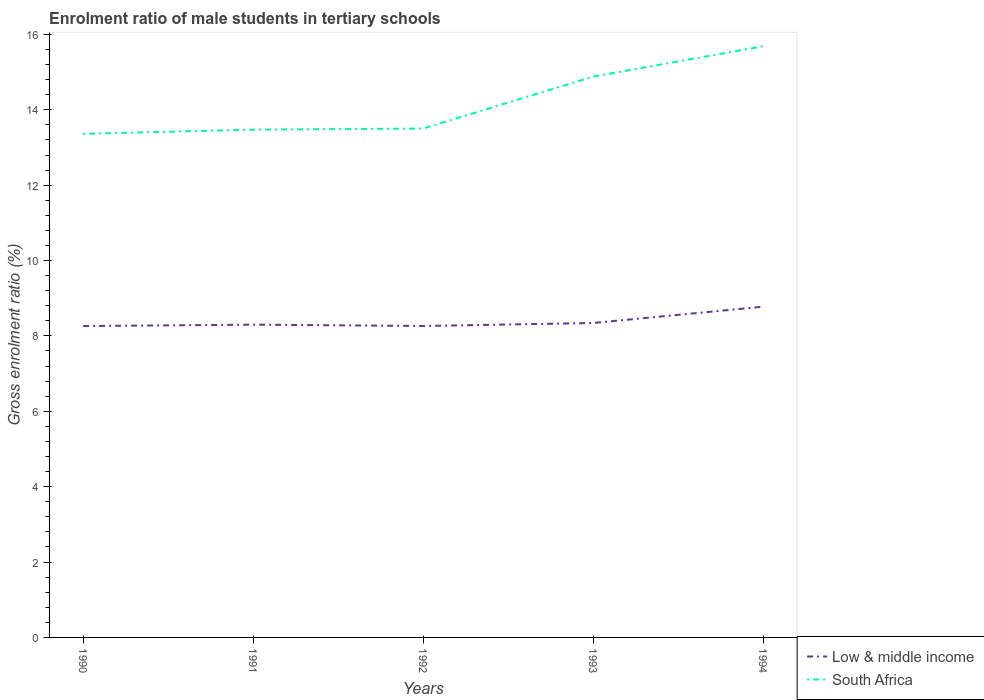How many different coloured lines are there?
Offer a terse response. 2. Is the number of lines equal to the number of legend labels?
Ensure brevity in your answer.  Yes. Across all years, what is the maximum enrolment ratio of male students in tertiary schools in South Africa?
Offer a very short reply. 13.36. What is the total enrolment ratio of male students in tertiary schools in South Africa in the graph?
Your answer should be compact. -1.41. What is the difference between the highest and the second highest enrolment ratio of male students in tertiary schools in South Africa?
Your answer should be compact. 2.32. Is the enrolment ratio of male students in tertiary schools in South Africa strictly greater than the enrolment ratio of male students in tertiary schools in Low & middle income over the years?
Keep it short and to the point. No. How many lines are there?
Offer a very short reply. 2. How many years are there in the graph?
Give a very brief answer. 5. Are the values on the major ticks of Y-axis written in scientific E-notation?
Provide a short and direct response. No. Does the graph contain any zero values?
Ensure brevity in your answer.  No. How many legend labels are there?
Offer a very short reply. 2. How are the legend labels stacked?
Provide a short and direct response. Vertical. What is the title of the graph?
Provide a short and direct response. Enrolment ratio of male students in tertiary schools. What is the label or title of the Y-axis?
Give a very brief answer. Gross enrolment ratio (%). What is the Gross enrolment ratio (%) in Low & middle income in 1990?
Your answer should be very brief. 8.26. What is the Gross enrolment ratio (%) in South Africa in 1990?
Provide a succinct answer. 13.36. What is the Gross enrolment ratio (%) of Low & middle income in 1991?
Ensure brevity in your answer.  8.3. What is the Gross enrolment ratio (%) in South Africa in 1991?
Provide a short and direct response. 13.47. What is the Gross enrolment ratio (%) of Low & middle income in 1992?
Offer a very short reply. 8.26. What is the Gross enrolment ratio (%) of South Africa in 1992?
Keep it short and to the point. 13.5. What is the Gross enrolment ratio (%) in Low & middle income in 1993?
Offer a terse response. 8.34. What is the Gross enrolment ratio (%) in South Africa in 1993?
Provide a succinct answer. 14.88. What is the Gross enrolment ratio (%) of Low & middle income in 1994?
Make the answer very short. 8.78. What is the Gross enrolment ratio (%) in South Africa in 1994?
Make the answer very short. 15.69. Across all years, what is the maximum Gross enrolment ratio (%) of Low & middle income?
Ensure brevity in your answer.  8.78. Across all years, what is the maximum Gross enrolment ratio (%) of South Africa?
Ensure brevity in your answer.  15.69. Across all years, what is the minimum Gross enrolment ratio (%) in Low & middle income?
Keep it short and to the point. 8.26. Across all years, what is the minimum Gross enrolment ratio (%) in South Africa?
Your response must be concise. 13.36. What is the total Gross enrolment ratio (%) in Low & middle income in the graph?
Provide a short and direct response. 41.94. What is the total Gross enrolment ratio (%) in South Africa in the graph?
Give a very brief answer. 70.9. What is the difference between the Gross enrolment ratio (%) in Low & middle income in 1990 and that in 1991?
Your response must be concise. -0.04. What is the difference between the Gross enrolment ratio (%) in South Africa in 1990 and that in 1991?
Your answer should be very brief. -0.11. What is the difference between the Gross enrolment ratio (%) of Low & middle income in 1990 and that in 1992?
Your answer should be very brief. -0. What is the difference between the Gross enrolment ratio (%) of South Africa in 1990 and that in 1992?
Your response must be concise. -0.14. What is the difference between the Gross enrolment ratio (%) of Low & middle income in 1990 and that in 1993?
Your answer should be compact. -0.08. What is the difference between the Gross enrolment ratio (%) of South Africa in 1990 and that in 1993?
Offer a terse response. -1.52. What is the difference between the Gross enrolment ratio (%) in Low & middle income in 1990 and that in 1994?
Your answer should be compact. -0.51. What is the difference between the Gross enrolment ratio (%) in South Africa in 1990 and that in 1994?
Your response must be concise. -2.32. What is the difference between the Gross enrolment ratio (%) of Low & middle income in 1991 and that in 1992?
Offer a terse response. 0.04. What is the difference between the Gross enrolment ratio (%) of South Africa in 1991 and that in 1992?
Keep it short and to the point. -0.03. What is the difference between the Gross enrolment ratio (%) in Low & middle income in 1991 and that in 1993?
Provide a short and direct response. -0.04. What is the difference between the Gross enrolment ratio (%) of South Africa in 1991 and that in 1993?
Keep it short and to the point. -1.41. What is the difference between the Gross enrolment ratio (%) in Low & middle income in 1991 and that in 1994?
Your answer should be very brief. -0.48. What is the difference between the Gross enrolment ratio (%) in South Africa in 1991 and that in 1994?
Provide a short and direct response. -2.21. What is the difference between the Gross enrolment ratio (%) of Low & middle income in 1992 and that in 1993?
Offer a very short reply. -0.08. What is the difference between the Gross enrolment ratio (%) in South Africa in 1992 and that in 1993?
Provide a succinct answer. -1.38. What is the difference between the Gross enrolment ratio (%) of Low & middle income in 1992 and that in 1994?
Make the answer very short. -0.51. What is the difference between the Gross enrolment ratio (%) of South Africa in 1992 and that in 1994?
Offer a very short reply. -2.18. What is the difference between the Gross enrolment ratio (%) in Low & middle income in 1993 and that in 1994?
Ensure brevity in your answer.  -0.43. What is the difference between the Gross enrolment ratio (%) of South Africa in 1993 and that in 1994?
Ensure brevity in your answer.  -0.81. What is the difference between the Gross enrolment ratio (%) of Low & middle income in 1990 and the Gross enrolment ratio (%) of South Africa in 1991?
Keep it short and to the point. -5.21. What is the difference between the Gross enrolment ratio (%) of Low & middle income in 1990 and the Gross enrolment ratio (%) of South Africa in 1992?
Your answer should be compact. -5.24. What is the difference between the Gross enrolment ratio (%) in Low & middle income in 1990 and the Gross enrolment ratio (%) in South Africa in 1993?
Make the answer very short. -6.62. What is the difference between the Gross enrolment ratio (%) in Low & middle income in 1990 and the Gross enrolment ratio (%) in South Africa in 1994?
Provide a succinct answer. -7.42. What is the difference between the Gross enrolment ratio (%) in Low & middle income in 1991 and the Gross enrolment ratio (%) in South Africa in 1992?
Offer a very short reply. -5.2. What is the difference between the Gross enrolment ratio (%) in Low & middle income in 1991 and the Gross enrolment ratio (%) in South Africa in 1993?
Offer a terse response. -6.58. What is the difference between the Gross enrolment ratio (%) in Low & middle income in 1991 and the Gross enrolment ratio (%) in South Africa in 1994?
Ensure brevity in your answer.  -7.39. What is the difference between the Gross enrolment ratio (%) in Low & middle income in 1992 and the Gross enrolment ratio (%) in South Africa in 1993?
Ensure brevity in your answer.  -6.62. What is the difference between the Gross enrolment ratio (%) of Low & middle income in 1992 and the Gross enrolment ratio (%) of South Africa in 1994?
Make the answer very short. -7.42. What is the difference between the Gross enrolment ratio (%) of Low & middle income in 1993 and the Gross enrolment ratio (%) of South Africa in 1994?
Give a very brief answer. -7.34. What is the average Gross enrolment ratio (%) in Low & middle income per year?
Your answer should be compact. 8.39. What is the average Gross enrolment ratio (%) in South Africa per year?
Keep it short and to the point. 14.18. In the year 1990, what is the difference between the Gross enrolment ratio (%) in Low & middle income and Gross enrolment ratio (%) in South Africa?
Provide a short and direct response. -5.1. In the year 1991, what is the difference between the Gross enrolment ratio (%) in Low & middle income and Gross enrolment ratio (%) in South Africa?
Ensure brevity in your answer.  -5.17. In the year 1992, what is the difference between the Gross enrolment ratio (%) in Low & middle income and Gross enrolment ratio (%) in South Africa?
Offer a very short reply. -5.24. In the year 1993, what is the difference between the Gross enrolment ratio (%) in Low & middle income and Gross enrolment ratio (%) in South Africa?
Provide a succinct answer. -6.54. In the year 1994, what is the difference between the Gross enrolment ratio (%) in Low & middle income and Gross enrolment ratio (%) in South Africa?
Your answer should be very brief. -6.91. What is the ratio of the Gross enrolment ratio (%) of Low & middle income in 1990 to that in 1991?
Ensure brevity in your answer.  1. What is the ratio of the Gross enrolment ratio (%) in South Africa in 1990 to that in 1991?
Provide a succinct answer. 0.99. What is the ratio of the Gross enrolment ratio (%) of Low & middle income in 1990 to that in 1992?
Offer a very short reply. 1. What is the ratio of the Gross enrolment ratio (%) of Low & middle income in 1990 to that in 1993?
Offer a terse response. 0.99. What is the ratio of the Gross enrolment ratio (%) in South Africa in 1990 to that in 1993?
Your answer should be very brief. 0.9. What is the ratio of the Gross enrolment ratio (%) in Low & middle income in 1990 to that in 1994?
Provide a succinct answer. 0.94. What is the ratio of the Gross enrolment ratio (%) in South Africa in 1990 to that in 1994?
Provide a succinct answer. 0.85. What is the ratio of the Gross enrolment ratio (%) of Low & middle income in 1991 to that in 1993?
Provide a short and direct response. 0.99. What is the ratio of the Gross enrolment ratio (%) in South Africa in 1991 to that in 1993?
Your answer should be compact. 0.91. What is the ratio of the Gross enrolment ratio (%) in Low & middle income in 1991 to that in 1994?
Offer a very short reply. 0.95. What is the ratio of the Gross enrolment ratio (%) in South Africa in 1991 to that in 1994?
Provide a short and direct response. 0.86. What is the ratio of the Gross enrolment ratio (%) of South Africa in 1992 to that in 1993?
Your response must be concise. 0.91. What is the ratio of the Gross enrolment ratio (%) in Low & middle income in 1992 to that in 1994?
Provide a succinct answer. 0.94. What is the ratio of the Gross enrolment ratio (%) of South Africa in 1992 to that in 1994?
Provide a short and direct response. 0.86. What is the ratio of the Gross enrolment ratio (%) in Low & middle income in 1993 to that in 1994?
Keep it short and to the point. 0.95. What is the ratio of the Gross enrolment ratio (%) of South Africa in 1993 to that in 1994?
Your response must be concise. 0.95. What is the difference between the highest and the second highest Gross enrolment ratio (%) of Low & middle income?
Keep it short and to the point. 0.43. What is the difference between the highest and the second highest Gross enrolment ratio (%) in South Africa?
Offer a terse response. 0.81. What is the difference between the highest and the lowest Gross enrolment ratio (%) of Low & middle income?
Give a very brief answer. 0.51. What is the difference between the highest and the lowest Gross enrolment ratio (%) of South Africa?
Provide a succinct answer. 2.32. 